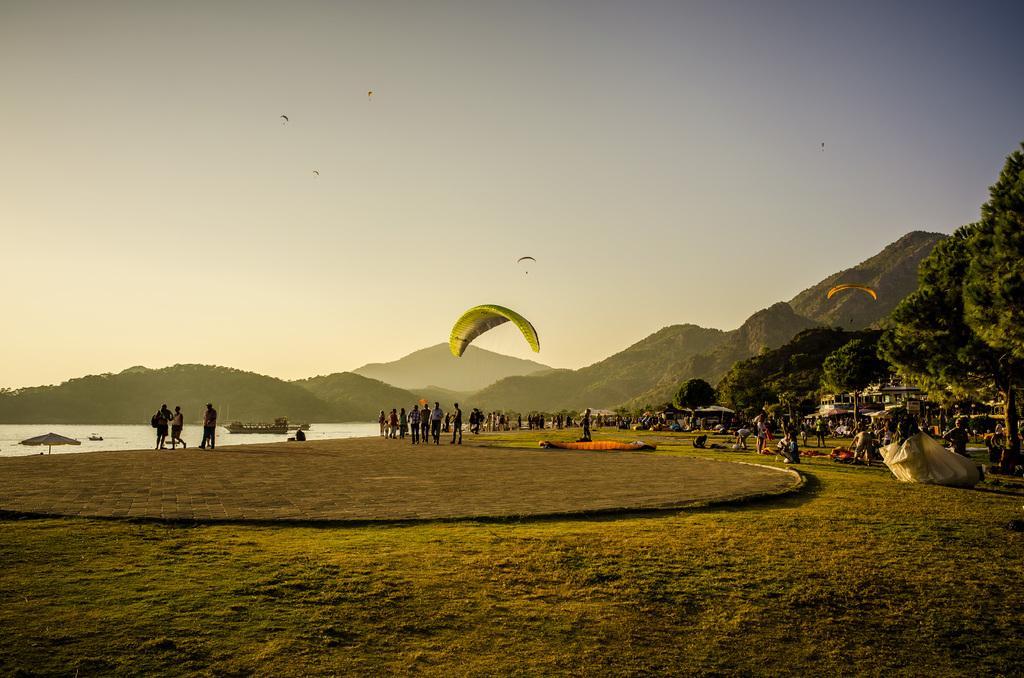Could you give a brief overview of what you see in this image? We can see paragliding in the air and we can grass and people. In the background we can see houses,boats above the water,trees,hills and sky. 